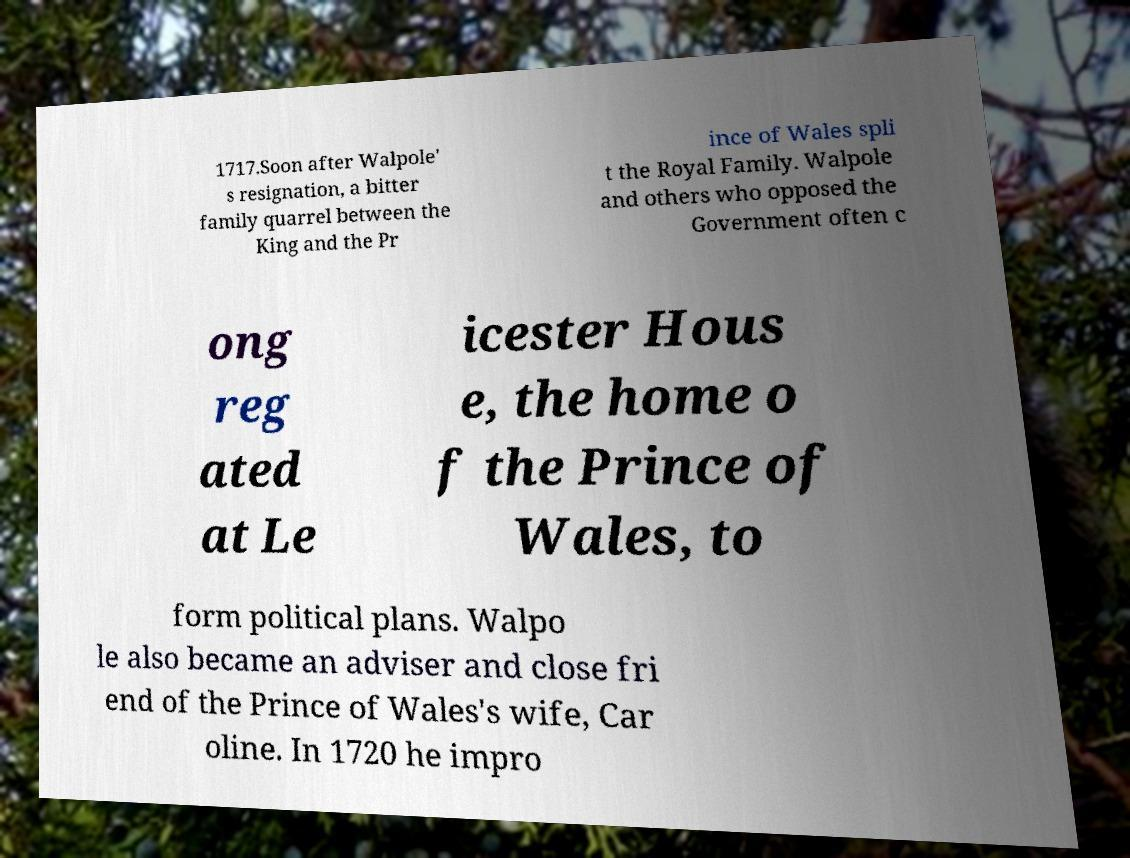Please identify and transcribe the text found in this image. 1717.Soon after Walpole' s resignation, a bitter family quarrel between the King and the Pr ince of Wales spli t the Royal Family. Walpole and others who opposed the Government often c ong reg ated at Le icester Hous e, the home o f the Prince of Wales, to form political plans. Walpo le also became an adviser and close fri end of the Prince of Wales's wife, Car oline. In 1720 he impro 